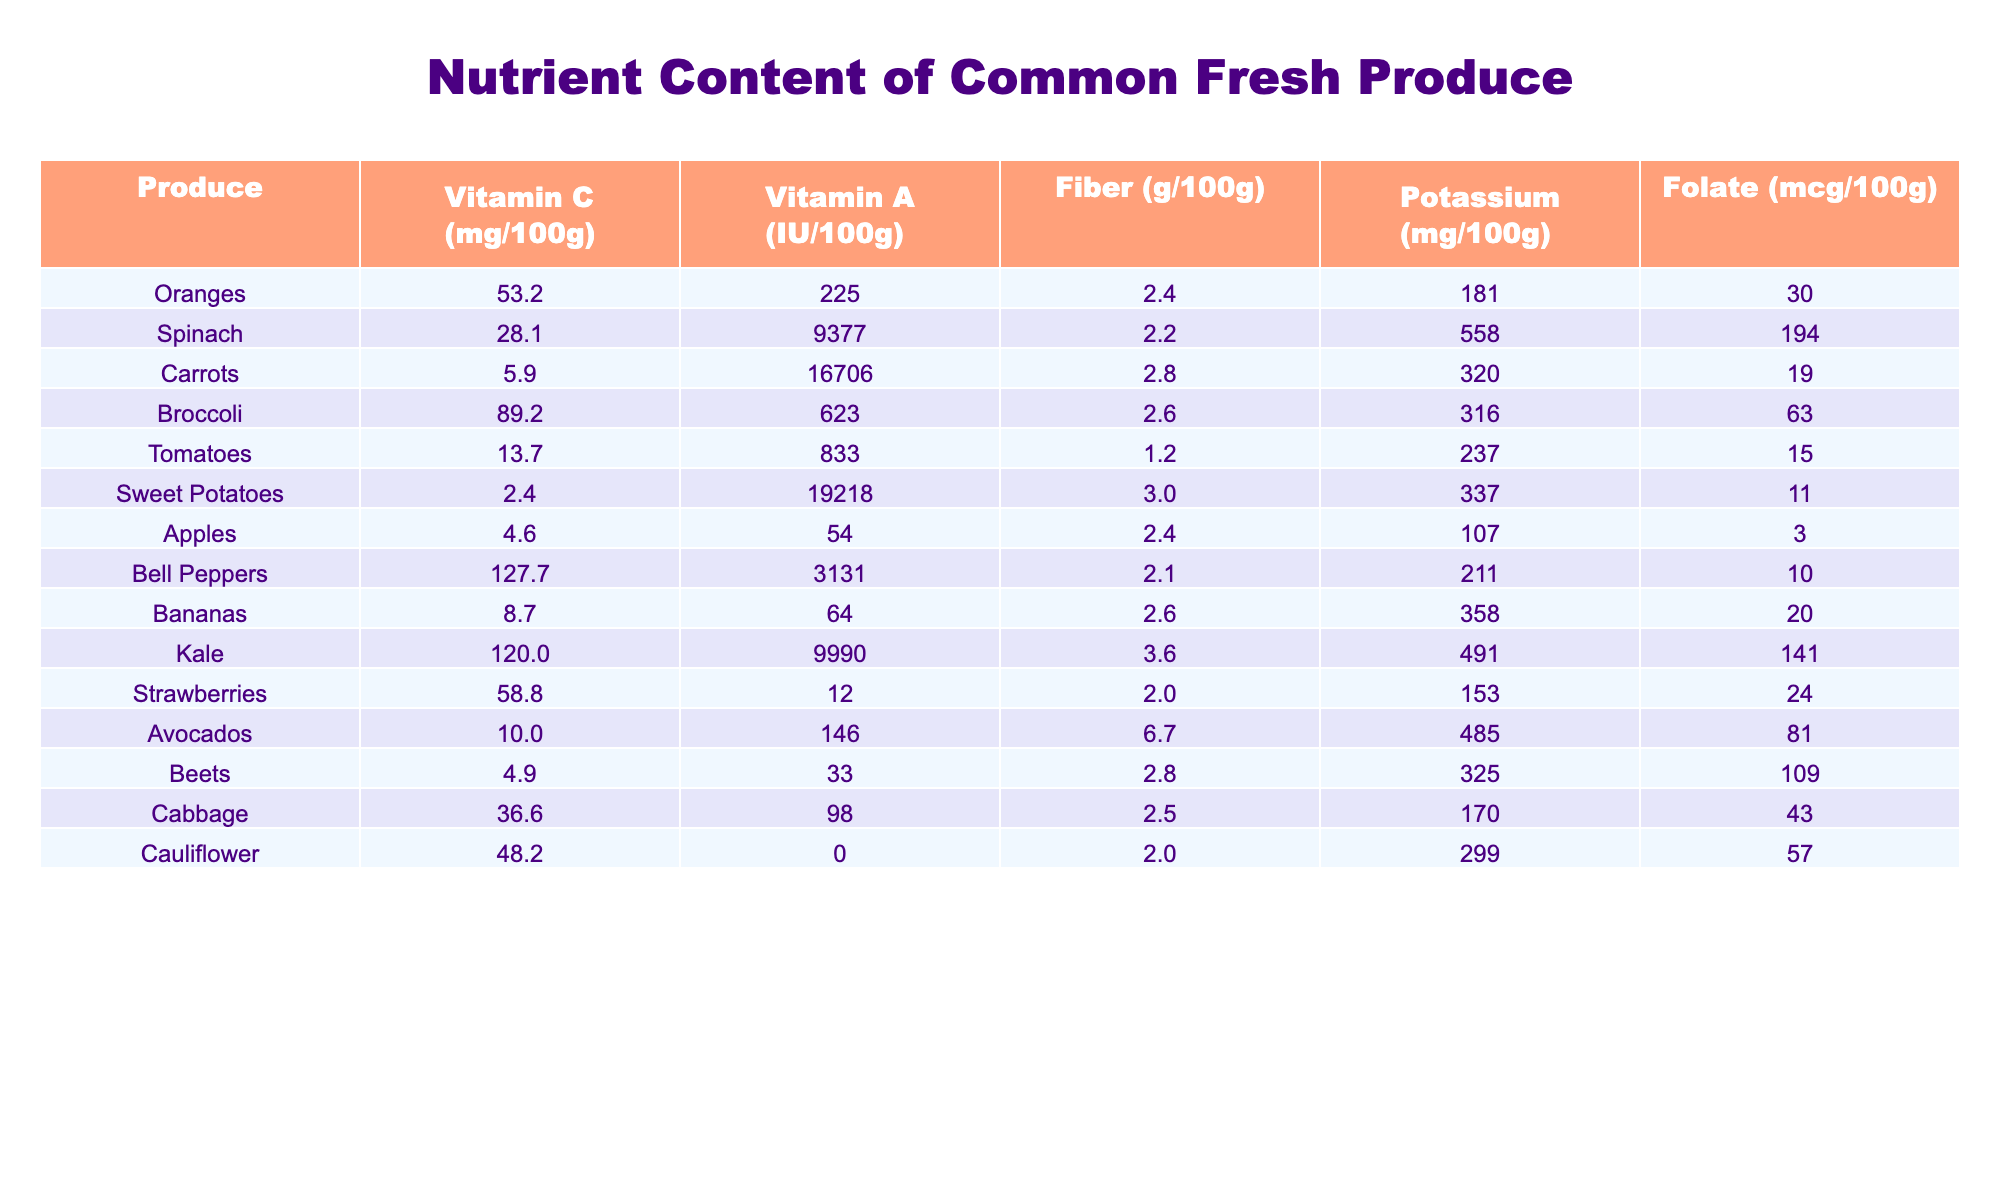What is the vitamin C content in Oranges? Looking at the table, the vitamin C content in Oranges is listed as 53.2 mg per 100g.
Answer: 53.2 mg Which produce has the highest vitamin A content? Referencing the table, Carrots have the highest vitamin A content, which is 16706 IU per 100g, compared to other items.
Answer: Carrots What is the fiber content in Spinach compared to Kale? From the table, Spinach has a fiber content of 2.2 g per 100g, whereas Kale has 3.6 g. To compare, Kale has 1.4 g more fiber than Spinach (3.6 - 2.2 = 1.4).
Answer: Kale has 1.4 g more fiber than Spinach Is the folate content in Tomatoes higher than in Bananas? The table shows that Tomatoes have a folate content of 15 mcg per 100g, while Bananas have 20 mcg. Therefore, the folate content in Tomatoes is lower than in Bananas.
Answer: No What is the average potassium content of Bell Peppers and Avocados? According to the table, Bell Peppers have 211 mg and Avocados have 485 mg of potassium. To find the average, add the two values (211 + 485 = 696) and divide by 2, which results in an average of 348 mg.
Answer: 348 mg How much Vitamin C is contained in Broccoli compared to Cabbage? From the table, Broccoli contains 89.2 mg of Vitamin C, while Cabbage has 36.6 mg. The difference is 89.2 - 36.6 = 52.6 mg, indicating Broccoli has significantly more Vitamin C than Cabbage.
Answer: Broccoli has 52.6 mg more Vitamin C than Cabbage Which two produce items have the highest Fiber content? By examining the table, the highest fiber content is in Sweet Potatoes (3.0 g) and Kale (3.6 g), indicating they are the top two items.
Answer: Kale and Sweet Potatoes Is it true that Apples contain more Vitamin A than Cauliflower? The table shows that Apples have a Vitamin A content of 54 IU and Cauliflower has none (0 IU). Thus, is it true that Apples contain more Vitamin A than Cauliflower? Yes.
Answer: Yes What is the total amount of Vitamin C in Oranges and Strawberries combined? The Vitamin C content in Oranges is 53.2 mg and in Strawberries, it is 58.8 mg. Adding these together (53.2 + 58.8 = 112 mg) gives a total Vitamin C content.
Answer: 112 mg How does the Fiber content in bananas compare to that in Carrots? Bananas have 2.6 g of fiber as listed in the table, while Carrots contain 2.8 g. Thus, Carrots have 0.2 g more fiber than Bananas (2.8 - 2.6 = 0.2).
Answer: Carrots have 0.2 g more fiber than Bananas 